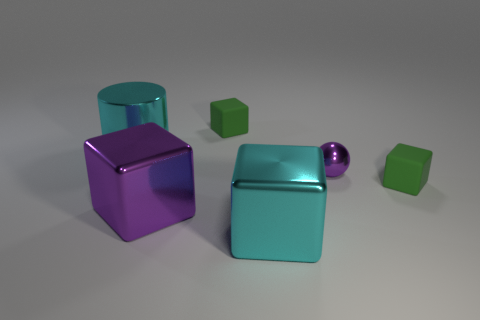What is the color of the cylinder that is made of the same material as the small purple thing?
Make the answer very short. Cyan. What number of big purple objects have the same material as the tiny purple sphere?
Provide a succinct answer. 1. There is a large block that is to the left of the big cyan shiny cube; is its color the same as the shiny ball?
Offer a very short reply. Yes. What number of other rubber things are the same shape as the big purple thing?
Ensure brevity in your answer.  2. Are there an equal number of large purple objects that are in front of the purple cube and small red cubes?
Give a very brief answer. Yes. What color is the cylinder that is the same size as the cyan metal block?
Your response must be concise. Cyan. Are there any other shiny objects that have the same shape as the large purple thing?
Provide a short and direct response. Yes. There is a green object behind the cyan shiny thing that is on the left side of the purple object that is in front of the purple ball; what is it made of?
Make the answer very short. Rubber. What is the color of the large metal cylinder?
Ensure brevity in your answer.  Cyan. How many rubber objects are either big purple spheres or cyan blocks?
Provide a succinct answer. 0. 